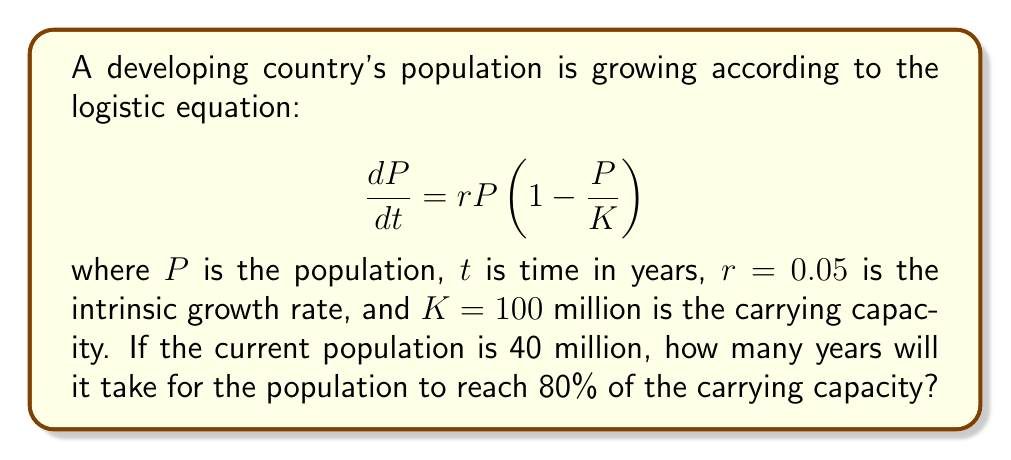Provide a solution to this math problem. To solve this problem, we need to use the analytical solution of the logistic equation and apply it to our specific scenario. The steps are as follows:

1) The analytical solution of the logistic equation is:

   $$P(t) = \frac{K}{1 + (\frac{K}{P_0} - 1)e^{-rt}}$$

   where $P_0$ is the initial population.

2) We're given:
   - $K = 100$ million
   - $r = 0.05$
   - $P_0 = 40$ million
   - We want to find $t$ when $P(t) = 0.8K = 80$ million

3) Let's substitute these values into the equation:

   $$80 = \frac{100}{1 + (\frac{100}{40} - 1)e^{-0.05t}}$$

4) Simplify:

   $$80 = \frac{100}{1 + 1.5e^{-0.05t}}$$

5) Multiply both sides by the denominator:

   $$80(1 + 1.5e^{-0.05t}) = 100$$

6) Expand:

   $$80 + 120e^{-0.05t} = 100$$

7) Subtract 80 from both sides:

   $$120e^{-0.05t} = 20$$

8) Divide both sides by 120:

   $$e^{-0.05t} = \frac{1}{6}$$

9) Take the natural log of both sides:

   $$-0.05t = \ln(\frac{1}{6})$$

10) Divide both sides by -0.05:

    $$t = -\frac{\ln(\frac{1}{6})}{0.05}$$

11) Calculate the final result:

    $$t \approx 35.67$$

Therefore, it will take approximately 35.67 years for the population to reach 80% of the carrying capacity.
Answer: 35.67 years 